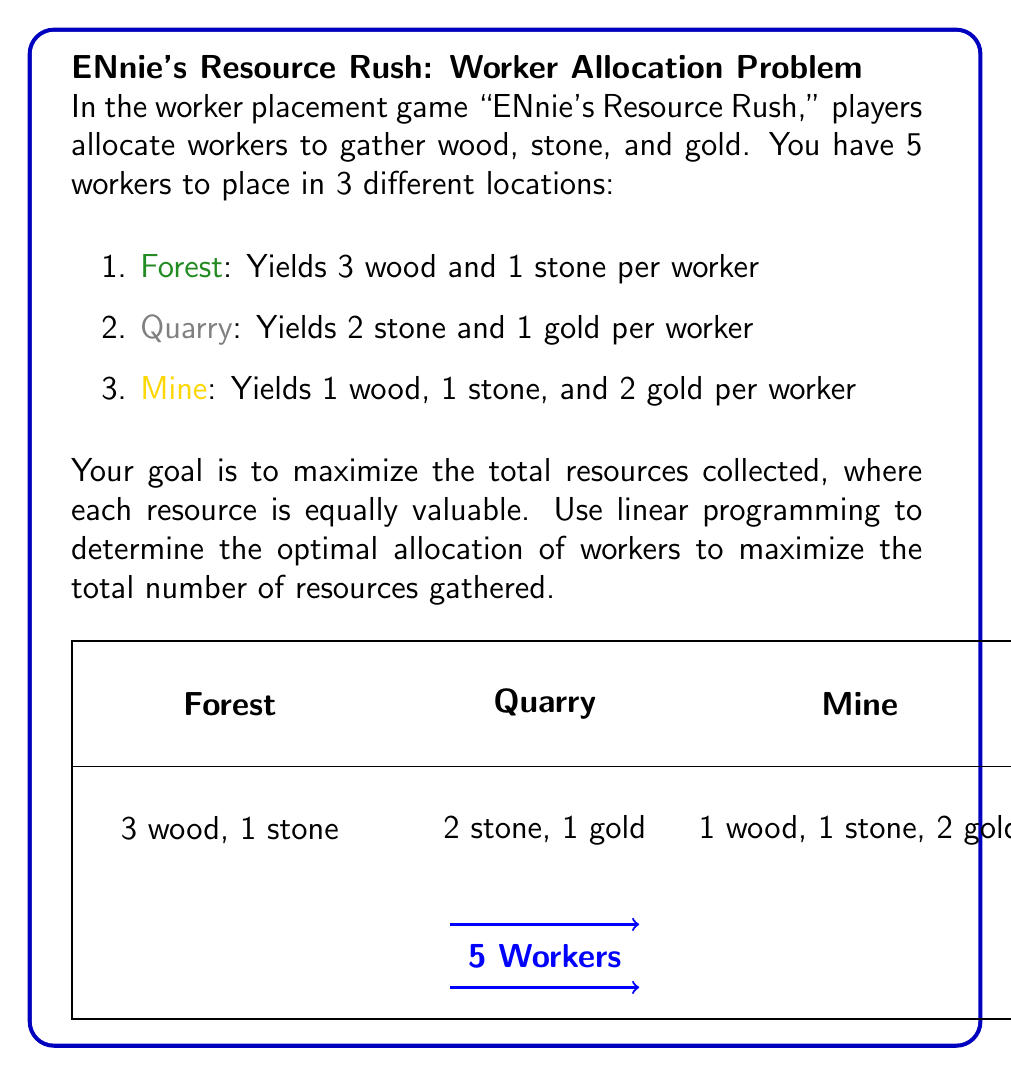Give your solution to this math problem. Let's solve this problem using linear programming:

1) Define variables:
   Let $x$, $y$, and $z$ be the number of workers allocated to the Forest, Quarry, and Mine respectively.

2) Set up the objective function:
   We want to maximize the total resources. Each worker contributes:
   - In Forest: 3 + 1 = 4 resources
   - In Quarry: 2 + 1 = 3 resources
   - In Mine: 1 + 1 + 2 = 4 resources
   
   Objective function: Maximize $4x + 3y + 4z$

3) Define constraints:
   - Total workers: $x + y + z \leq 5$
   - Non-negativity: $x, y, z \geq 0$

4) Set up the linear programming problem:
   $$\begin{align*}
   \text{Maximize:}& \quad 4x + 3y + 4z \\
   \text{Subject to:}& \quad x + y + z \leq 5 \\
   & \quad x, y, z \geq 0
   \end{align*}$$

5) Solve using the simplex method or graphical method:
   The optimal solution is $x = 2.5$, $y = 0$, $z = 2.5$

6) Since we can't allocate fractional workers, we need to consider integer solutions:
   The two best integer solutions are:
   a) $x = 3$, $y = 0$, $z = 2$ (Total resources: $3(4) + 0(3) + 2(4) = 20$)
   b) $x = 2$, $y = 0$, $z = 3$ (Total resources: $2(4) + 0(3) + 3(4) = 20$)

Both solutions yield the same maximum number of resources (20).
Answer: Allocate 2 or 3 workers to the Forest, 0 to the Quarry, and 3 or 2 to the Mine respectively, gathering 20 resources. 